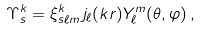<formula> <loc_0><loc_0><loc_500><loc_500>\Upsilon ^ { k } _ { s } = \xi ^ { k } _ { s \ell m } \, j _ { \ell } ( k r ) Y ^ { m } _ { \ell } ( \theta , \varphi ) \, ,</formula> 